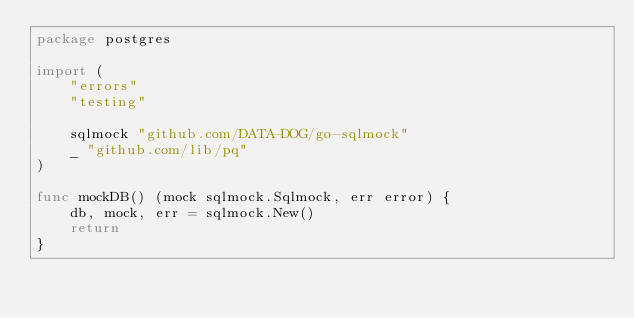Convert code to text. <code><loc_0><loc_0><loc_500><loc_500><_Go_>package postgres

import (
	"errors"
	"testing"

	sqlmock "github.com/DATA-DOG/go-sqlmock"
	_ "github.com/lib/pq"
)

func mockDB() (mock sqlmock.Sqlmock, err error) {
	db, mock, err = sqlmock.New()
	return
}
</code> 